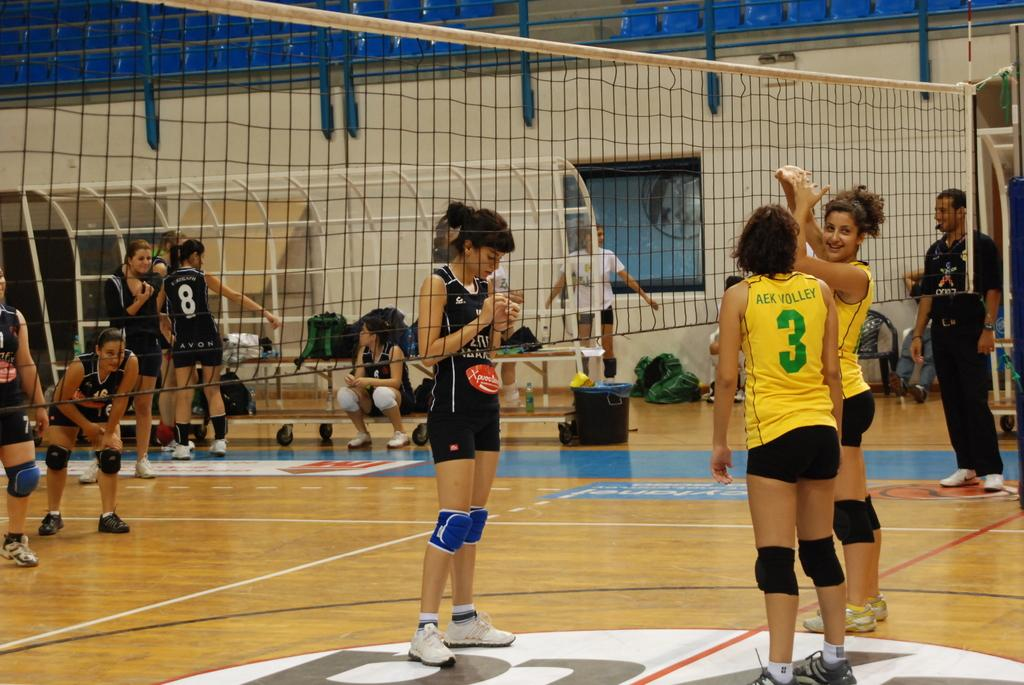<image>
Write a terse but informative summary of the picture. Woman wearing a yellow jersey with a number 3 on a volleyball court. 